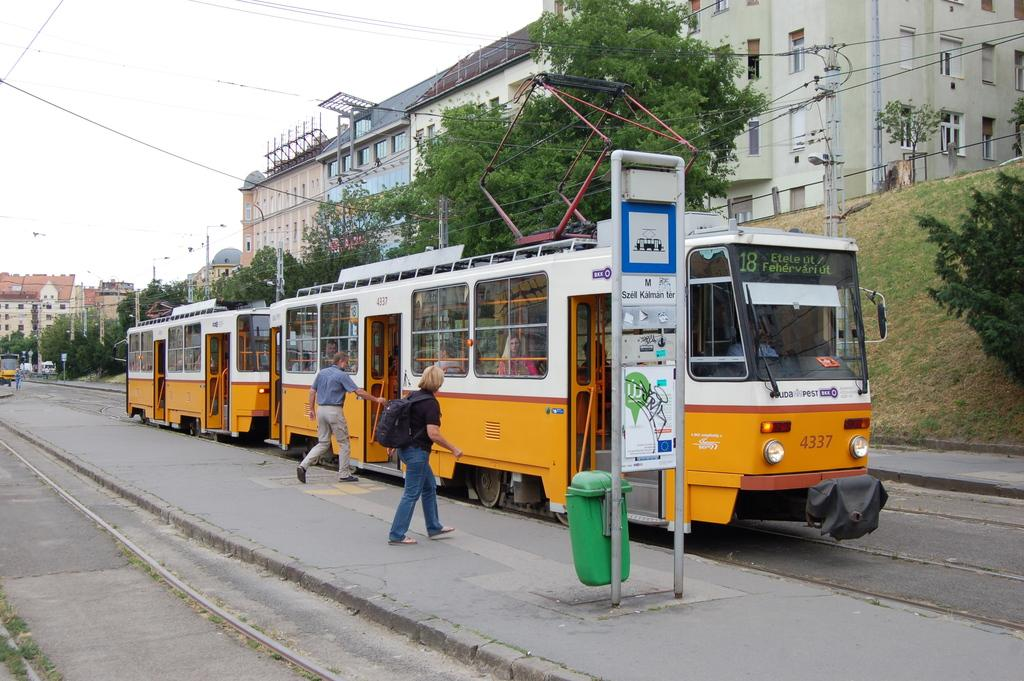What mode of transportation is featured in the image? There is a street train in the image. What are the two persons in the image doing? Two persons are boarding the train. Can you describe any specific features in the image? There is a pole and a dustbin in the image. What can be seen in the background of the image? There are trees, buildings, and the sky visible in the background of the image. What type of quince is being used as a decoration on the street train? There is no quince present in the image, and therefore no such decoration can be observed. Can you tell me how many yaks are visible in the background of the image? There are no yaks present in the image; the background features trees, buildings, and the sky. 